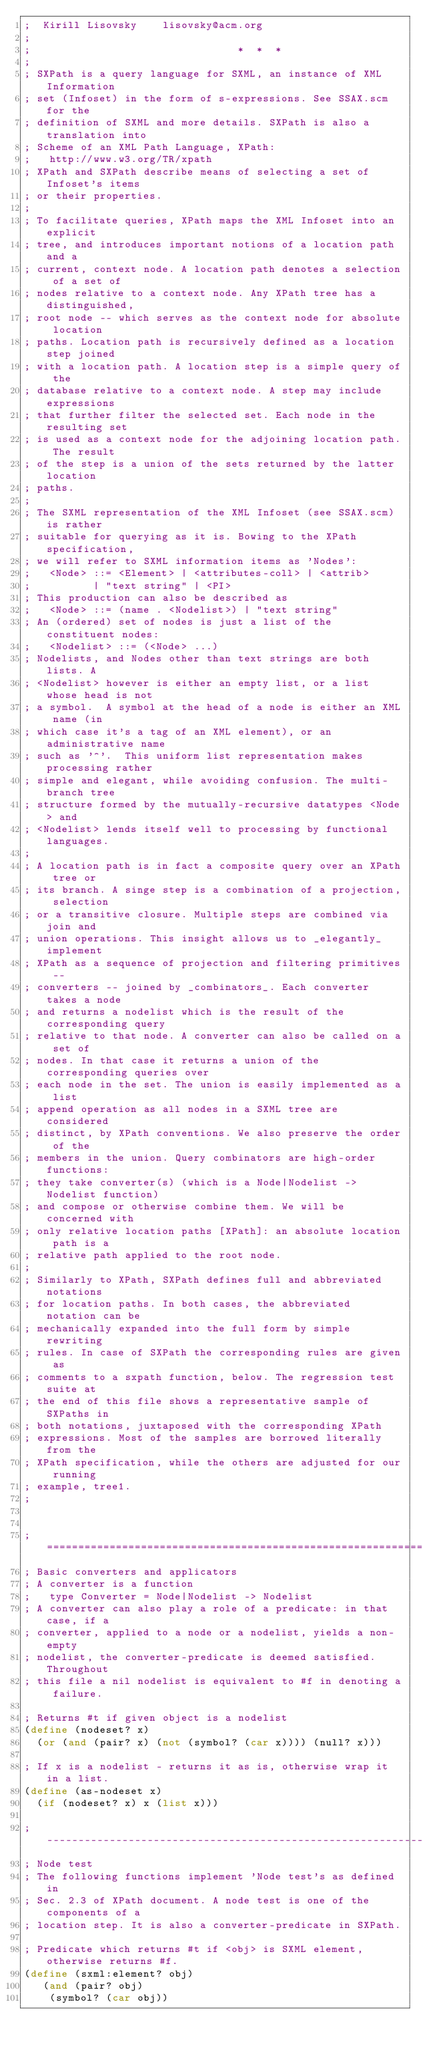<code> <loc_0><loc_0><loc_500><loc_500><_Scheme_>;  Kirill Lisovsky    lisovsky@acm.org
;
;                                 *  *  *
;
; SXPath is a query language for SXML, an instance of XML Information
; set (Infoset) in the form of s-expressions. See SSAX.scm for the
; definition of SXML and more details. SXPath is also a translation into
; Scheme of an XML Path Language, XPath:
;	http://www.w3.org/TR/xpath
; XPath and SXPath describe means of selecting a set of Infoset's items
; or their properties.
;
; To facilitate queries, XPath maps the XML Infoset into an explicit
; tree, and introduces important notions of a location path and a
; current, context node. A location path denotes a selection of a set of
; nodes relative to a context node. Any XPath tree has a distinguished,
; root node -- which serves as the context node for absolute location
; paths. Location path is recursively defined as a location step joined
; with a location path. A location step is a simple query of the
; database relative to a context node. A step may include expressions
; that further filter the selected set. Each node in the resulting set
; is used as a context node for the adjoining location path. The result
; of the step is a union of the sets returned by the latter location
; paths.
;
; The SXML representation of the XML Infoset (see SSAX.scm) is rather
; suitable for querying as it is. Bowing to the XPath specification,
; we will refer to SXML information items as 'Nodes':
; 	<Node> ::= <Element> | <attributes-coll> | <attrib>
; 		   | "text string" | <PI>
; This production can also be described as
;	<Node> ::= (name . <Nodelist>) | "text string"
; An (ordered) set of nodes is just a list of the constituent nodes:
; 	<Nodelist> ::= (<Node> ...)
; Nodelists, and Nodes other than text strings are both lists. A
; <Nodelist> however is either an empty list, or a list whose head is not
; a symbol.  A symbol at the head of a node is either an XML name (in
; which case it's a tag of an XML element), or an administrative name
; such as '^'.  This uniform list representation makes processing rather
; simple and elegant, while avoiding confusion. The multi-branch tree
; structure formed by the mutually-recursive datatypes <Node> and
; <Nodelist> lends itself well to processing by functional languages.
;
; A location path is in fact a composite query over an XPath tree or
; its branch. A singe step is a combination of a projection, selection
; or a transitive closure. Multiple steps are combined via join and
; union operations. This insight allows us to _elegantly_ implement
; XPath as a sequence of projection and filtering primitives --
; converters -- joined by _combinators_. Each converter takes a node
; and returns a nodelist which is the result of the corresponding query
; relative to that node. A converter can also be called on a set of
; nodes. In that case it returns a union of the corresponding queries over
; each node in the set. The union is easily implemented as a list
; append operation as all nodes in a SXML tree are considered
; distinct, by XPath conventions. We also preserve the order of the
; members in the union. Query combinators are high-order functions:
; they take converter(s) (which is a Node|Nodelist -> Nodelist function)
; and compose or otherwise combine them. We will be concerned with
; only relative location paths [XPath]: an absolute location path is a
; relative path applied to the root node.
;
; Similarly to XPath, SXPath defines full and abbreviated notations
; for location paths. In both cases, the abbreviated notation can be
; mechanically expanded into the full form by simple rewriting
; rules. In case of SXPath the corresponding rules are given as
; comments to a sxpath function, below. The regression test suite at
; the end of this file shows a representative sample of SXPaths in
; both notations, juxtaposed with the corresponding XPath
; expressions. Most of the samples are borrowed literally from the
; XPath specification, while the others are adjusted for our running
; example, tree1.
;


;=============================================================================
; Basic converters and applicators
; A converter is a function
;	type Converter = Node|Nodelist -> Nodelist
; A converter can also play a role of a predicate: in that case, if a
; converter, applied to a node or a nodelist, yields a non-empty
; nodelist, the converter-predicate is deemed satisfied. Throughout
; this file a nil nodelist is equivalent to #f in denoting a failure.

; Returns #t if given object is a nodelist
(define (nodeset? x)
  (or (and (pair? x) (not (symbol? (car x)))) (null? x)))

; If x is a nodelist - returns it as is, otherwise wrap it in a list.
(define (as-nodeset x)
  (if (nodeset? x) x (list x)))

;-----------------------------------------------------------------------------
; Node test
; The following functions implement 'Node test's as defined in
; Sec. 2.3 of XPath document. A node test is one of the components of a
; location step. It is also a converter-predicate in SXPath.

; Predicate which returns #t if <obj> is SXML element, otherwise returns #f. 
(define (sxml:element? obj)	
   (and (pair? obj)
	(symbol? (car obj))</code> 